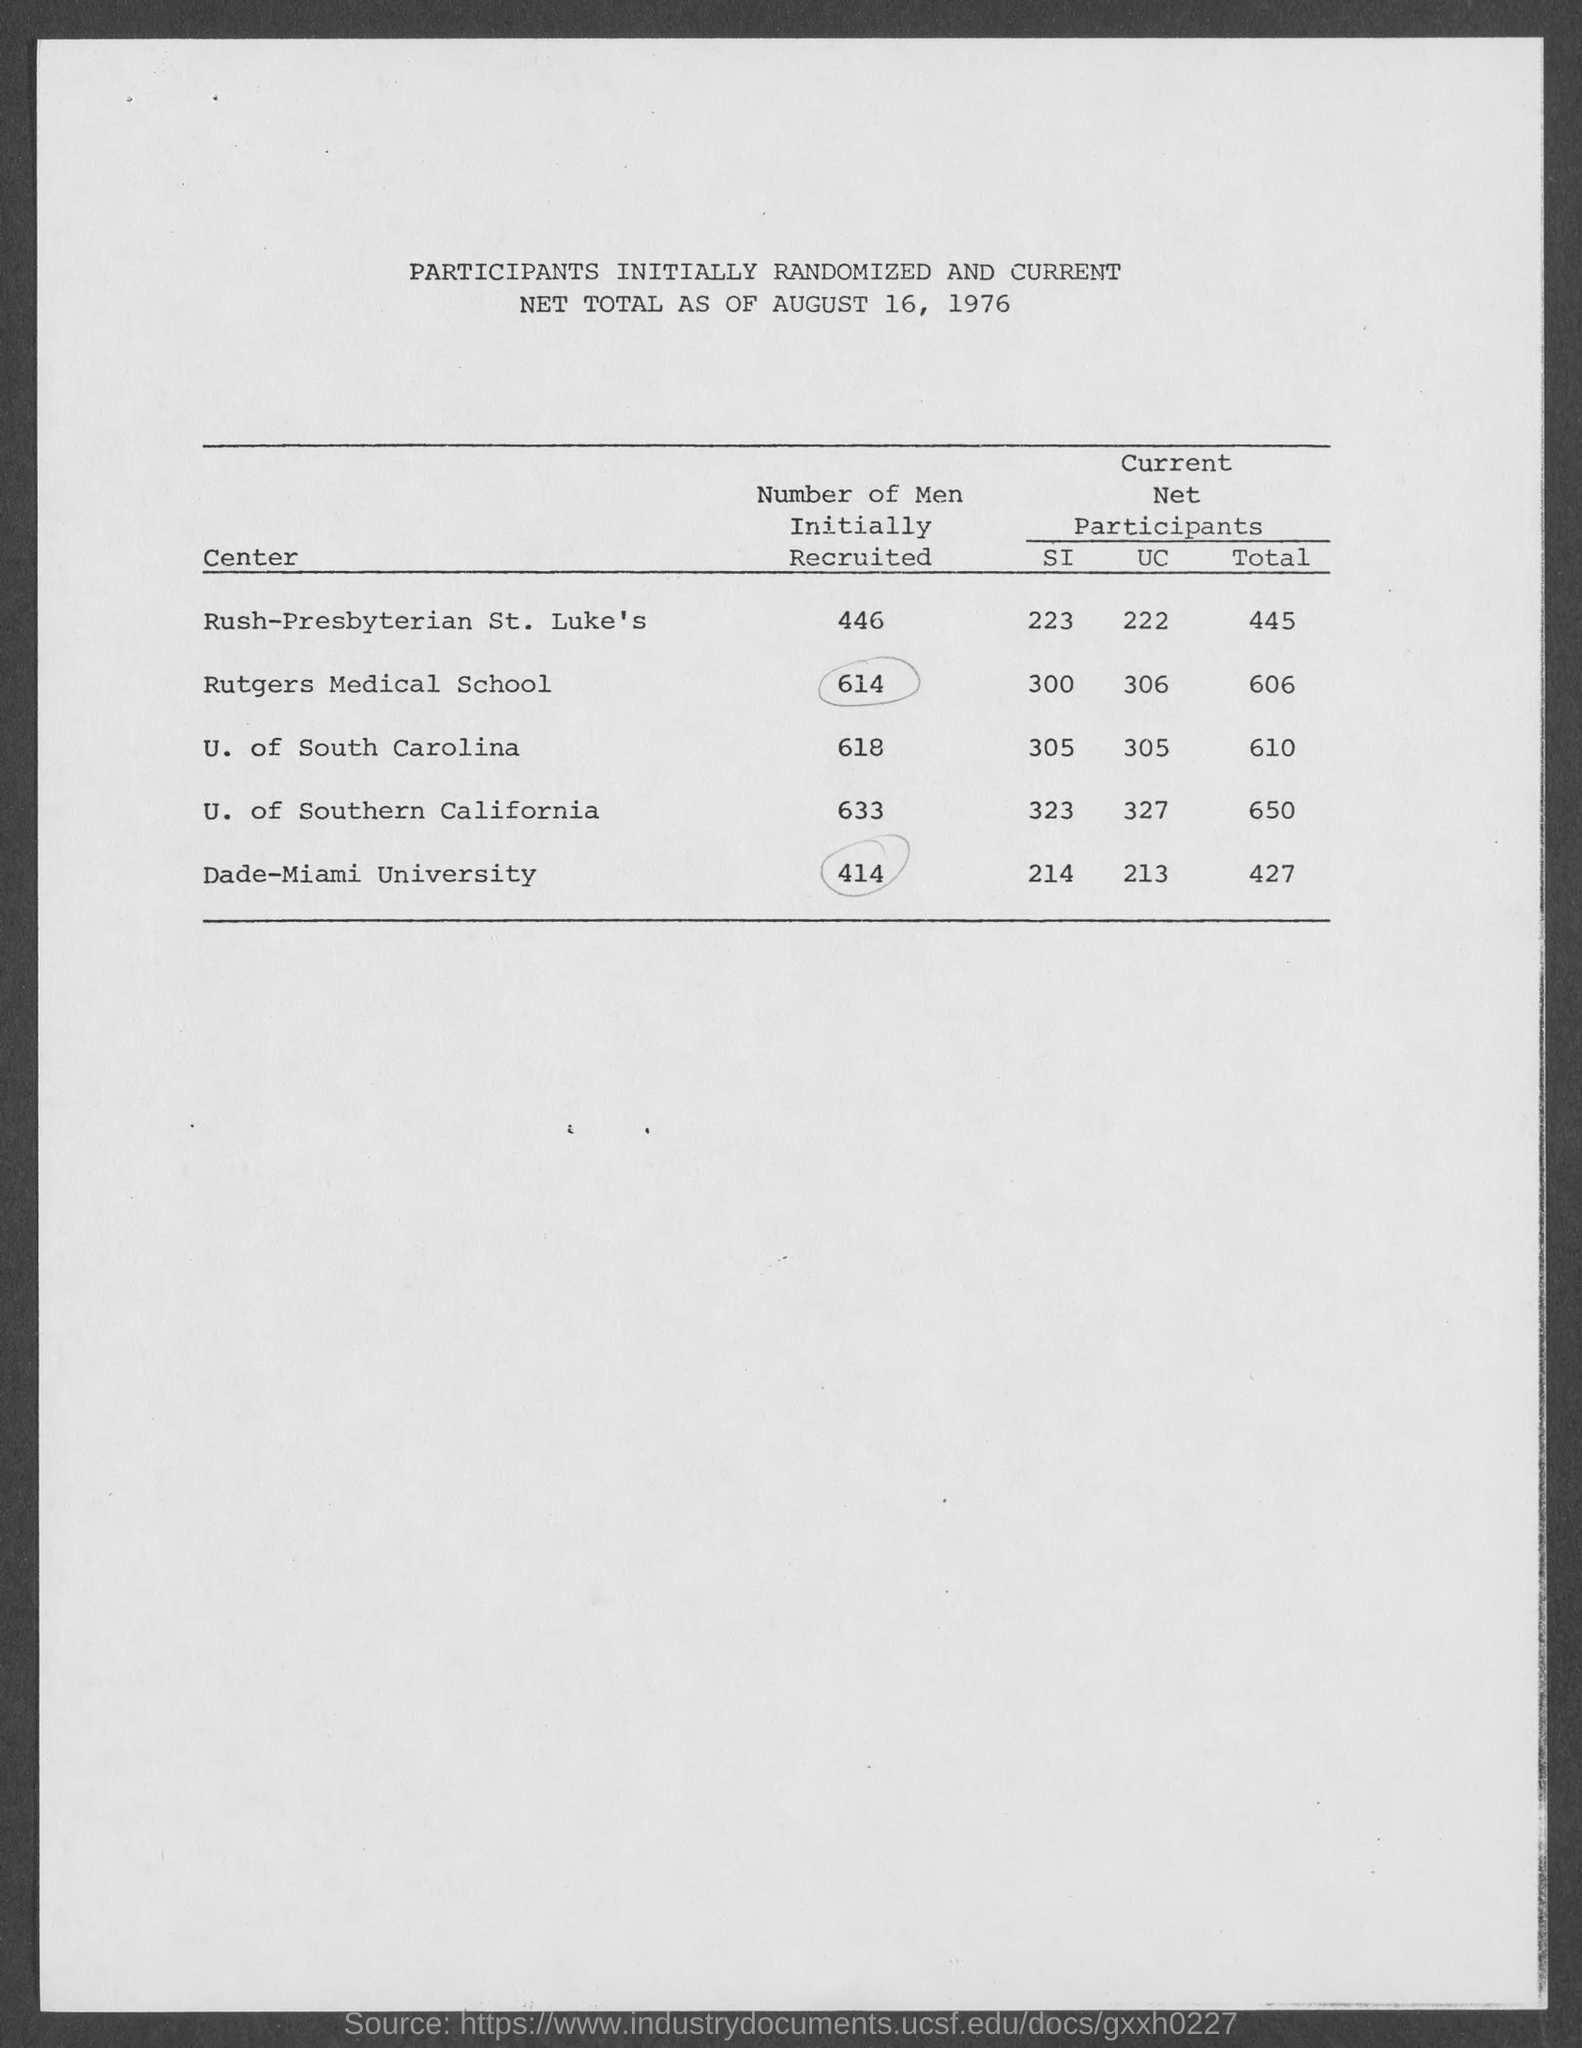Mention a couple of crucial points in this snapshot. According to records, a total of 633 men were initially recruited at the University of Southern California for a specific purpose. The University of South Carolina initially recruited 618 men for the purpose of serving in the military. 414 men were initially recruited at the Dade-Miami University. 